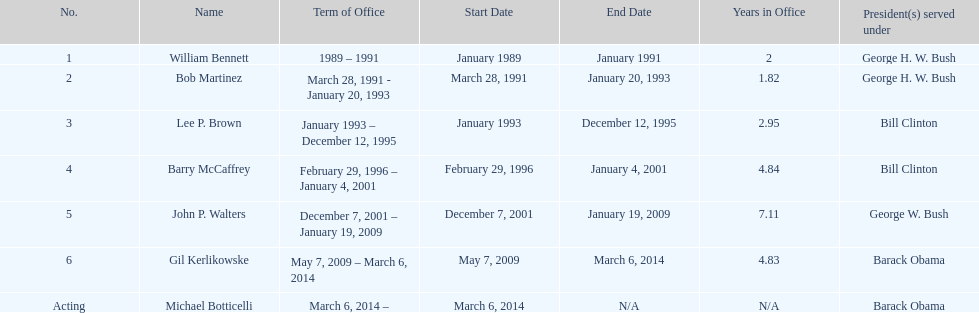Who serves inder barack obama? Gil Kerlikowske. 